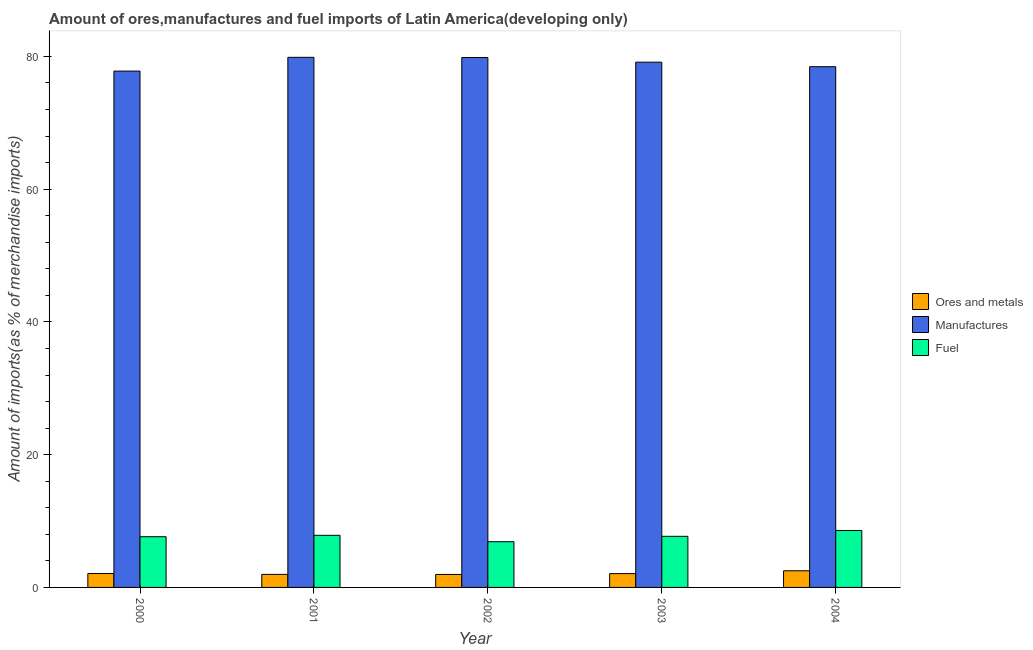How many different coloured bars are there?
Your answer should be very brief. 3. How many bars are there on the 5th tick from the left?
Provide a succinct answer. 3. How many bars are there on the 2nd tick from the right?
Give a very brief answer. 3. What is the label of the 2nd group of bars from the left?
Your response must be concise. 2001. What is the percentage of manufactures imports in 2001?
Make the answer very short. 79.86. Across all years, what is the maximum percentage of fuel imports?
Your answer should be compact. 8.58. Across all years, what is the minimum percentage of manufactures imports?
Offer a terse response. 77.79. In which year was the percentage of fuel imports minimum?
Provide a short and direct response. 2002. What is the total percentage of manufactures imports in the graph?
Offer a very short reply. 395.06. What is the difference between the percentage of manufactures imports in 2003 and that in 2004?
Keep it short and to the point. 0.68. What is the difference between the percentage of fuel imports in 2003 and the percentage of ores and metals imports in 2002?
Give a very brief answer. 0.81. What is the average percentage of fuel imports per year?
Your answer should be compact. 7.73. In how many years, is the percentage of fuel imports greater than 36 %?
Provide a succinct answer. 0. What is the ratio of the percentage of ores and metals imports in 2003 to that in 2004?
Your answer should be very brief. 0.83. Is the difference between the percentage of manufactures imports in 2000 and 2003 greater than the difference between the percentage of ores and metals imports in 2000 and 2003?
Ensure brevity in your answer.  No. What is the difference between the highest and the second highest percentage of manufactures imports?
Your answer should be compact. 0.03. What is the difference between the highest and the lowest percentage of manufactures imports?
Keep it short and to the point. 2.07. What does the 3rd bar from the left in 2002 represents?
Your answer should be very brief. Fuel. What does the 3rd bar from the right in 2000 represents?
Your answer should be compact. Ores and metals. How many years are there in the graph?
Provide a short and direct response. 5. What is the difference between two consecutive major ticks on the Y-axis?
Offer a very short reply. 20. Are the values on the major ticks of Y-axis written in scientific E-notation?
Keep it short and to the point. No. Does the graph contain any zero values?
Keep it short and to the point. No. Does the graph contain grids?
Give a very brief answer. No. What is the title of the graph?
Ensure brevity in your answer.  Amount of ores,manufactures and fuel imports of Latin America(developing only). What is the label or title of the Y-axis?
Ensure brevity in your answer.  Amount of imports(as % of merchandise imports). What is the Amount of imports(as % of merchandise imports) of Ores and metals in 2000?
Offer a very short reply. 2.1. What is the Amount of imports(as % of merchandise imports) in Manufactures in 2000?
Make the answer very short. 77.79. What is the Amount of imports(as % of merchandise imports) of Fuel in 2000?
Offer a very short reply. 7.64. What is the Amount of imports(as % of merchandise imports) in Ores and metals in 2001?
Make the answer very short. 1.96. What is the Amount of imports(as % of merchandise imports) in Manufactures in 2001?
Your answer should be compact. 79.86. What is the Amount of imports(as % of merchandise imports) of Fuel in 2001?
Make the answer very short. 7.85. What is the Amount of imports(as % of merchandise imports) of Ores and metals in 2002?
Give a very brief answer. 1.95. What is the Amount of imports(as % of merchandise imports) in Manufactures in 2002?
Give a very brief answer. 79.83. What is the Amount of imports(as % of merchandise imports) of Fuel in 2002?
Give a very brief answer. 6.89. What is the Amount of imports(as % of merchandise imports) of Ores and metals in 2003?
Your response must be concise. 2.08. What is the Amount of imports(as % of merchandise imports) in Manufactures in 2003?
Keep it short and to the point. 79.13. What is the Amount of imports(as % of merchandise imports) in Fuel in 2003?
Make the answer very short. 7.7. What is the Amount of imports(as % of merchandise imports) in Ores and metals in 2004?
Make the answer very short. 2.51. What is the Amount of imports(as % of merchandise imports) of Manufactures in 2004?
Provide a short and direct response. 78.45. What is the Amount of imports(as % of merchandise imports) in Fuel in 2004?
Provide a short and direct response. 8.58. Across all years, what is the maximum Amount of imports(as % of merchandise imports) in Ores and metals?
Keep it short and to the point. 2.51. Across all years, what is the maximum Amount of imports(as % of merchandise imports) of Manufactures?
Provide a succinct answer. 79.86. Across all years, what is the maximum Amount of imports(as % of merchandise imports) in Fuel?
Provide a succinct answer. 8.58. Across all years, what is the minimum Amount of imports(as % of merchandise imports) of Ores and metals?
Your response must be concise. 1.95. Across all years, what is the minimum Amount of imports(as % of merchandise imports) of Manufactures?
Ensure brevity in your answer.  77.79. Across all years, what is the minimum Amount of imports(as % of merchandise imports) of Fuel?
Your answer should be very brief. 6.89. What is the total Amount of imports(as % of merchandise imports) of Ores and metals in the graph?
Make the answer very short. 10.61. What is the total Amount of imports(as % of merchandise imports) of Manufactures in the graph?
Offer a terse response. 395.06. What is the total Amount of imports(as % of merchandise imports) of Fuel in the graph?
Provide a short and direct response. 38.66. What is the difference between the Amount of imports(as % of merchandise imports) of Ores and metals in 2000 and that in 2001?
Offer a terse response. 0.13. What is the difference between the Amount of imports(as % of merchandise imports) of Manufactures in 2000 and that in 2001?
Your answer should be very brief. -2.07. What is the difference between the Amount of imports(as % of merchandise imports) of Fuel in 2000 and that in 2001?
Give a very brief answer. -0.21. What is the difference between the Amount of imports(as % of merchandise imports) of Ores and metals in 2000 and that in 2002?
Keep it short and to the point. 0.14. What is the difference between the Amount of imports(as % of merchandise imports) of Manufactures in 2000 and that in 2002?
Your answer should be very brief. -2.04. What is the difference between the Amount of imports(as % of merchandise imports) of Fuel in 2000 and that in 2002?
Make the answer very short. 0.75. What is the difference between the Amount of imports(as % of merchandise imports) in Ores and metals in 2000 and that in 2003?
Ensure brevity in your answer.  0.01. What is the difference between the Amount of imports(as % of merchandise imports) in Manufactures in 2000 and that in 2003?
Make the answer very short. -1.34. What is the difference between the Amount of imports(as % of merchandise imports) of Fuel in 2000 and that in 2003?
Offer a terse response. -0.06. What is the difference between the Amount of imports(as % of merchandise imports) of Ores and metals in 2000 and that in 2004?
Ensure brevity in your answer.  -0.41. What is the difference between the Amount of imports(as % of merchandise imports) of Manufactures in 2000 and that in 2004?
Offer a very short reply. -0.66. What is the difference between the Amount of imports(as % of merchandise imports) of Fuel in 2000 and that in 2004?
Your response must be concise. -0.94. What is the difference between the Amount of imports(as % of merchandise imports) in Ores and metals in 2001 and that in 2002?
Give a very brief answer. 0.01. What is the difference between the Amount of imports(as % of merchandise imports) of Manufactures in 2001 and that in 2002?
Make the answer very short. 0.03. What is the difference between the Amount of imports(as % of merchandise imports) of Fuel in 2001 and that in 2002?
Offer a terse response. 0.96. What is the difference between the Amount of imports(as % of merchandise imports) in Ores and metals in 2001 and that in 2003?
Offer a very short reply. -0.12. What is the difference between the Amount of imports(as % of merchandise imports) of Manufactures in 2001 and that in 2003?
Offer a terse response. 0.73. What is the difference between the Amount of imports(as % of merchandise imports) of Fuel in 2001 and that in 2003?
Give a very brief answer. 0.15. What is the difference between the Amount of imports(as % of merchandise imports) in Ores and metals in 2001 and that in 2004?
Provide a short and direct response. -0.54. What is the difference between the Amount of imports(as % of merchandise imports) of Manufactures in 2001 and that in 2004?
Your answer should be compact. 1.41. What is the difference between the Amount of imports(as % of merchandise imports) of Fuel in 2001 and that in 2004?
Your answer should be very brief. -0.73. What is the difference between the Amount of imports(as % of merchandise imports) in Ores and metals in 2002 and that in 2003?
Offer a terse response. -0.13. What is the difference between the Amount of imports(as % of merchandise imports) in Manufactures in 2002 and that in 2003?
Your answer should be compact. 0.7. What is the difference between the Amount of imports(as % of merchandise imports) in Fuel in 2002 and that in 2003?
Give a very brief answer. -0.81. What is the difference between the Amount of imports(as % of merchandise imports) in Ores and metals in 2002 and that in 2004?
Provide a short and direct response. -0.55. What is the difference between the Amount of imports(as % of merchandise imports) of Manufactures in 2002 and that in 2004?
Your answer should be very brief. 1.38. What is the difference between the Amount of imports(as % of merchandise imports) in Fuel in 2002 and that in 2004?
Your answer should be very brief. -1.69. What is the difference between the Amount of imports(as % of merchandise imports) in Ores and metals in 2003 and that in 2004?
Keep it short and to the point. -0.42. What is the difference between the Amount of imports(as % of merchandise imports) of Manufactures in 2003 and that in 2004?
Your answer should be compact. 0.68. What is the difference between the Amount of imports(as % of merchandise imports) of Fuel in 2003 and that in 2004?
Ensure brevity in your answer.  -0.88. What is the difference between the Amount of imports(as % of merchandise imports) of Ores and metals in 2000 and the Amount of imports(as % of merchandise imports) of Manufactures in 2001?
Give a very brief answer. -77.76. What is the difference between the Amount of imports(as % of merchandise imports) in Ores and metals in 2000 and the Amount of imports(as % of merchandise imports) in Fuel in 2001?
Offer a terse response. -5.75. What is the difference between the Amount of imports(as % of merchandise imports) of Manufactures in 2000 and the Amount of imports(as % of merchandise imports) of Fuel in 2001?
Your response must be concise. 69.94. What is the difference between the Amount of imports(as % of merchandise imports) in Ores and metals in 2000 and the Amount of imports(as % of merchandise imports) in Manufactures in 2002?
Offer a terse response. -77.73. What is the difference between the Amount of imports(as % of merchandise imports) of Ores and metals in 2000 and the Amount of imports(as % of merchandise imports) of Fuel in 2002?
Give a very brief answer. -4.79. What is the difference between the Amount of imports(as % of merchandise imports) of Manufactures in 2000 and the Amount of imports(as % of merchandise imports) of Fuel in 2002?
Provide a succinct answer. 70.9. What is the difference between the Amount of imports(as % of merchandise imports) in Ores and metals in 2000 and the Amount of imports(as % of merchandise imports) in Manufactures in 2003?
Provide a short and direct response. -77.03. What is the difference between the Amount of imports(as % of merchandise imports) in Ores and metals in 2000 and the Amount of imports(as % of merchandise imports) in Fuel in 2003?
Keep it short and to the point. -5.6. What is the difference between the Amount of imports(as % of merchandise imports) of Manufactures in 2000 and the Amount of imports(as % of merchandise imports) of Fuel in 2003?
Provide a short and direct response. 70.09. What is the difference between the Amount of imports(as % of merchandise imports) of Ores and metals in 2000 and the Amount of imports(as % of merchandise imports) of Manufactures in 2004?
Provide a succinct answer. -76.35. What is the difference between the Amount of imports(as % of merchandise imports) in Ores and metals in 2000 and the Amount of imports(as % of merchandise imports) in Fuel in 2004?
Give a very brief answer. -6.48. What is the difference between the Amount of imports(as % of merchandise imports) of Manufactures in 2000 and the Amount of imports(as % of merchandise imports) of Fuel in 2004?
Keep it short and to the point. 69.21. What is the difference between the Amount of imports(as % of merchandise imports) in Ores and metals in 2001 and the Amount of imports(as % of merchandise imports) in Manufactures in 2002?
Offer a very short reply. -77.87. What is the difference between the Amount of imports(as % of merchandise imports) of Ores and metals in 2001 and the Amount of imports(as % of merchandise imports) of Fuel in 2002?
Provide a short and direct response. -4.92. What is the difference between the Amount of imports(as % of merchandise imports) of Manufactures in 2001 and the Amount of imports(as % of merchandise imports) of Fuel in 2002?
Keep it short and to the point. 72.97. What is the difference between the Amount of imports(as % of merchandise imports) in Ores and metals in 2001 and the Amount of imports(as % of merchandise imports) in Manufactures in 2003?
Make the answer very short. -77.16. What is the difference between the Amount of imports(as % of merchandise imports) of Ores and metals in 2001 and the Amount of imports(as % of merchandise imports) of Fuel in 2003?
Provide a succinct answer. -5.73. What is the difference between the Amount of imports(as % of merchandise imports) in Manufactures in 2001 and the Amount of imports(as % of merchandise imports) in Fuel in 2003?
Your answer should be very brief. 72.16. What is the difference between the Amount of imports(as % of merchandise imports) in Ores and metals in 2001 and the Amount of imports(as % of merchandise imports) in Manufactures in 2004?
Keep it short and to the point. -76.49. What is the difference between the Amount of imports(as % of merchandise imports) of Ores and metals in 2001 and the Amount of imports(as % of merchandise imports) of Fuel in 2004?
Your response must be concise. -6.61. What is the difference between the Amount of imports(as % of merchandise imports) of Manufactures in 2001 and the Amount of imports(as % of merchandise imports) of Fuel in 2004?
Make the answer very short. 71.28. What is the difference between the Amount of imports(as % of merchandise imports) of Ores and metals in 2002 and the Amount of imports(as % of merchandise imports) of Manufactures in 2003?
Offer a very short reply. -77.18. What is the difference between the Amount of imports(as % of merchandise imports) in Ores and metals in 2002 and the Amount of imports(as % of merchandise imports) in Fuel in 2003?
Provide a succinct answer. -5.75. What is the difference between the Amount of imports(as % of merchandise imports) of Manufactures in 2002 and the Amount of imports(as % of merchandise imports) of Fuel in 2003?
Your answer should be very brief. 72.13. What is the difference between the Amount of imports(as % of merchandise imports) in Ores and metals in 2002 and the Amount of imports(as % of merchandise imports) in Manufactures in 2004?
Provide a short and direct response. -76.5. What is the difference between the Amount of imports(as % of merchandise imports) in Ores and metals in 2002 and the Amount of imports(as % of merchandise imports) in Fuel in 2004?
Ensure brevity in your answer.  -6.62. What is the difference between the Amount of imports(as % of merchandise imports) of Manufactures in 2002 and the Amount of imports(as % of merchandise imports) of Fuel in 2004?
Provide a short and direct response. 71.25. What is the difference between the Amount of imports(as % of merchandise imports) of Ores and metals in 2003 and the Amount of imports(as % of merchandise imports) of Manufactures in 2004?
Give a very brief answer. -76.37. What is the difference between the Amount of imports(as % of merchandise imports) of Ores and metals in 2003 and the Amount of imports(as % of merchandise imports) of Fuel in 2004?
Your answer should be compact. -6.49. What is the difference between the Amount of imports(as % of merchandise imports) in Manufactures in 2003 and the Amount of imports(as % of merchandise imports) in Fuel in 2004?
Make the answer very short. 70.55. What is the average Amount of imports(as % of merchandise imports) of Ores and metals per year?
Make the answer very short. 2.12. What is the average Amount of imports(as % of merchandise imports) in Manufactures per year?
Your answer should be very brief. 79.01. What is the average Amount of imports(as % of merchandise imports) of Fuel per year?
Provide a succinct answer. 7.73. In the year 2000, what is the difference between the Amount of imports(as % of merchandise imports) in Ores and metals and Amount of imports(as % of merchandise imports) in Manufactures?
Ensure brevity in your answer.  -75.69. In the year 2000, what is the difference between the Amount of imports(as % of merchandise imports) in Ores and metals and Amount of imports(as % of merchandise imports) in Fuel?
Your answer should be compact. -5.54. In the year 2000, what is the difference between the Amount of imports(as % of merchandise imports) of Manufactures and Amount of imports(as % of merchandise imports) of Fuel?
Offer a very short reply. 70.15. In the year 2001, what is the difference between the Amount of imports(as % of merchandise imports) in Ores and metals and Amount of imports(as % of merchandise imports) in Manufactures?
Offer a very short reply. -77.9. In the year 2001, what is the difference between the Amount of imports(as % of merchandise imports) in Ores and metals and Amount of imports(as % of merchandise imports) in Fuel?
Provide a succinct answer. -5.89. In the year 2001, what is the difference between the Amount of imports(as % of merchandise imports) of Manufactures and Amount of imports(as % of merchandise imports) of Fuel?
Give a very brief answer. 72.01. In the year 2002, what is the difference between the Amount of imports(as % of merchandise imports) in Ores and metals and Amount of imports(as % of merchandise imports) in Manufactures?
Your response must be concise. -77.88. In the year 2002, what is the difference between the Amount of imports(as % of merchandise imports) of Ores and metals and Amount of imports(as % of merchandise imports) of Fuel?
Offer a very short reply. -4.93. In the year 2002, what is the difference between the Amount of imports(as % of merchandise imports) of Manufactures and Amount of imports(as % of merchandise imports) of Fuel?
Offer a very short reply. 72.94. In the year 2003, what is the difference between the Amount of imports(as % of merchandise imports) in Ores and metals and Amount of imports(as % of merchandise imports) in Manufactures?
Your response must be concise. -77.05. In the year 2003, what is the difference between the Amount of imports(as % of merchandise imports) in Ores and metals and Amount of imports(as % of merchandise imports) in Fuel?
Your answer should be very brief. -5.62. In the year 2003, what is the difference between the Amount of imports(as % of merchandise imports) of Manufactures and Amount of imports(as % of merchandise imports) of Fuel?
Keep it short and to the point. 71.43. In the year 2004, what is the difference between the Amount of imports(as % of merchandise imports) of Ores and metals and Amount of imports(as % of merchandise imports) of Manufactures?
Ensure brevity in your answer.  -75.94. In the year 2004, what is the difference between the Amount of imports(as % of merchandise imports) in Ores and metals and Amount of imports(as % of merchandise imports) in Fuel?
Your answer should be very brief. -6.07. In the year 2004, what is the difference between the Amount of imports(as % of merchandise imports) of Manufactures and Amount of imports(as % of merchandise imports) of Fuel?
Offer a very short reply. 69.87. What is the ratio of the Amount of imports(as % of merchandise imports) of Ores and metals in 2000 to that in 2001?
Keep it short and to the point. 1.07. What is the ratio of the Amount of imports(as % of merchandise imports) in Manufactures in 2000 to that in 2001?
Give a very brief answer. 0.97. What is the ratio of the Amount of imports(as % of merchandise imports) in Fuel in 2000 to that in 2001?
Your answer should be compact. 0.97. What is the ratio of the Amount of imports(as % of merchandise imports) in Ores and metals in 2000 to that in 2002?
Offer a very short reply. 1.07. What is the ratio of the Amount of imports(as % of merchandise imports) in Manufactures in 2000 to that in 2002?
Your response must be concise. 0.97. What is the ratio of the Amount of imports(as % of merchandise imports) in Fuel in 2000 to that in 2002?
Make the answer very short. 1.11. What is the ratio of the Amount of imports(as % of merchandise imports) of Ores and metals in 2000 to that in 2003?
Offer a terse response. 1.01. What is the ratio of the Amount of imports(as % of merchandise imports) in Manufactures in 2000 to that in 2003?
Provide a short and direct response. 0.98. What is the ratio of the Amount of imports(as % of merchandise imports) in Ores and metals in 2000 to that in 2004?
Keep it short and to the point. 0.84. What is the ratio of the Amount of imports(as % of merchandise imports) in Manufactures in 2000 to that in 2004?
Ensure brevity in your answer.  0.99. What is the ratio of the Amount of imports(as % of merchandise imports) of Fuel in 2000 to that in 2004?
Keep it short and to the point. 0.89. What is the ratio of the Amount of imports(as % of merchandise imports) of Manufactures in 2001 to that in 2002?
Offer a very short reply. 1. What is the ratio of the Amount of imports(as % of merchandise imports) in Fuel in 2001 to that in 2002?
Give a very brief answer. 1.14. What is the ratio of the Amount of imports(as % of merchandise imports) of Ores and metals in 2001 to that in 2003?
Your response must be concise. 0.94. What is the ratio of the Amount of imports(as % of merchandise imports) of Manufactures in 2001 to that in 2003?
Your answer should be compact. 1.01. What is the ratio of the Amount of imports(as % of merchandise imports) of Fuel in 2001 to that in 2003?
Keep it short and to the point. 1.02. What is the ratio of the Amount of imports(as % of merchandise imports) in Ores and metals in 2001 to that in 2004?
Make the answer very short. 0.78. What is the ratio of the Amount of imports(as % of merchandise imports) of Manufactures in 2001 to that in 2004?
Ensure brevity in your answer.  1.02. What is the ratio of the Amount of imports(as % of merchandise imports) of Fuel in 2001 to that in 2004?
Your answer should be compact. 0.92. What is the ratio of the Amount of imports(as % of merchandise imports) in Ores and metals in 2002 to that in 2003?
Your response must be concise. 0.94. What is the ratio of the Amount of imports(as % of merchandise imports) of Manufactures in 2002 to that in 2003?
Give a very brief answer. 1.01. What is the ratio of the Amount of imports(as % of merchandise imports) in Fuel in 2002 to that in 2003?
Provide a succinct answer. 0.89. What is the ratio of the Amount of imports(as % of merchandise imports) of Ores and metals in 2002 to that in 2004?
Your answer should be very brief. 0.78. What is the ratio of the Amount of imports(as % of merchandise imports) of Manufactures in 2002 to that in 2004?
Your response must be concise. 1.02. What is the ratio of the Amount of imports(as % of merchandise imports) of Fuel in 2002 to that in 2004?
Give a very brief answer. 0.8. What is the ratio of the Amount of imports(as % of merchandise imports) of Ores and metals in 2003 to that in 2004?
Provide a succinct answer. 0.83. What is the ratio of the Amount of imports(as % of merchandise imports) of Manufactures in 2003 to that in 2004?
Offer a very short reply. 1.01. What is the ratio of the Amount of imports(as % of merchandise imports) in Fuel in 2003 to that in 2004?
Provide a short and direct response. 0.9. What is the difference between the highest and the second highest Amount of imports(as % of merchandise imports) of Ores and metals?
Offer a terse response. 0.41. What is the difference between the highest and the second highest Amount of imports(as % of merchandise imports) in Manufactures?
Provide a succinct answer. 0.03. What is the difference between the highest and the second highest Amount of imports(as % of merchandise imports) in Fuel?
Your response must be concise. 0.73. What is the difference between the highest and the lowest Amount of imports(as % of merchandise imports) of Ores and metals?
Give a very brief answer. 0.55. What is the difference between the highest and the lowest Amount of imports(as % of merchandise imports) of Manufactures?
Keep it short and to the point. 2.07. What is the difference between the highest and the lowest Amount of imports(as % of merchandise imports) in Fuel?
Keep it short and to the point. 1.69. 